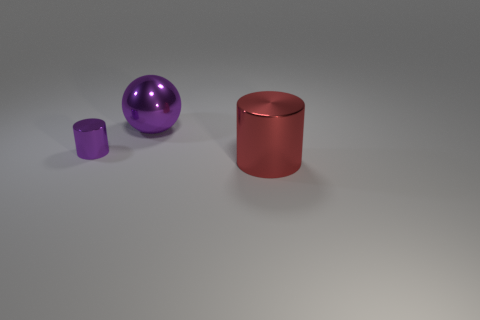How many spheres are there?
Provide a succinct answer. 1. There is a red thing; are there any big metallic objects right of it?
Keep it short and to the point. No. Are the cylinder on the right side of the big purple ball and the purple thing to the right of the small cylinder made of the same material?
Offer a terse response. Yes. Is the number of large purple shiny balls in front of the big purple shiny sphere less than the number of large metal cubes?
Ensure brevity in your answer.  No. What color is the thing that is behind the small object?
Offer a very short reply. Purple. What material is the object that is on the left side of the large metal thing that is behind the big shiny cylinder?
Offer a terse response. Metal. Are there any purple rubber balls of the same size as the purple metal sphere?
Provide a short and direct response. No. How many objects are either shiny cylinders that are right of the big purple metal object or metallic cylinders to the left of the red metal cylinder?
Make the answer very short. 2. Do the shiny cylinder that is behind the red metal object and the metal cylinder right of the big purple object have the same size?
Provide a succinct answer. No. There is a metal thing left of the large sphere; is there a red thing in front of it?
Ensure brevity in your answer.  Yes. 